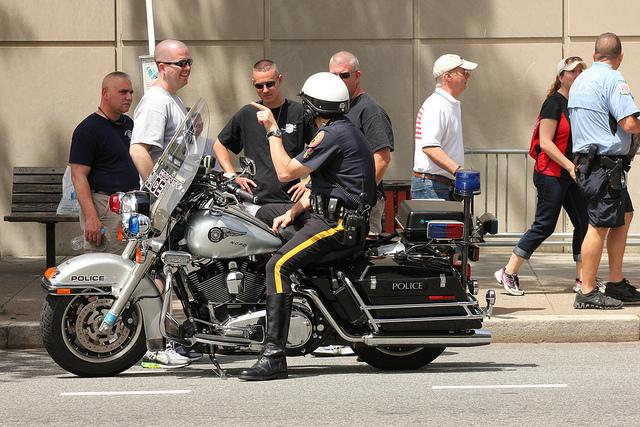How is the engine on this motorcycle cooled? air 